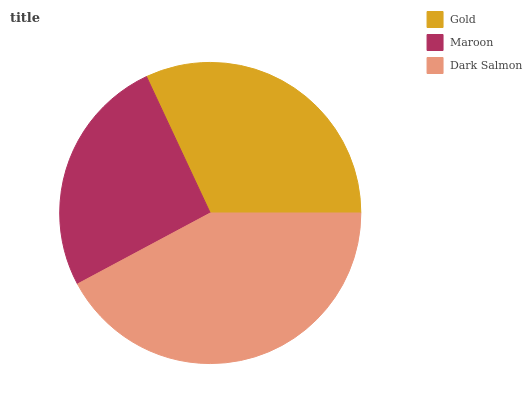Is Maroon the minimum?
Answer yes or no. Yes. Is Dark Salmon the maximum?
Answer yes or no. Yes. Is Dark Salmon the minimum?
Answer yes or no. No. Is Maroon the maximum?
Answer yes or no. No. Is Dark Salmon greater than Maroon?
Answer yes or no. Yes. Is Maroon less than Dark Salmon?
Answer yes or no. Yes. Is Maroon greater than Dark Salmon?
Answer yes or no. No. Is Dark Salmon less than Maroon?
Answer yes or no. No. Is Gold the high median?
Answer yes or no. Yes. Is Gold the low median?
Answer yes or no. Yes. Is Maroon the high median?
Answer yes or no. No. Is Dark Salmon the low median?
Answer yes or no. No. 